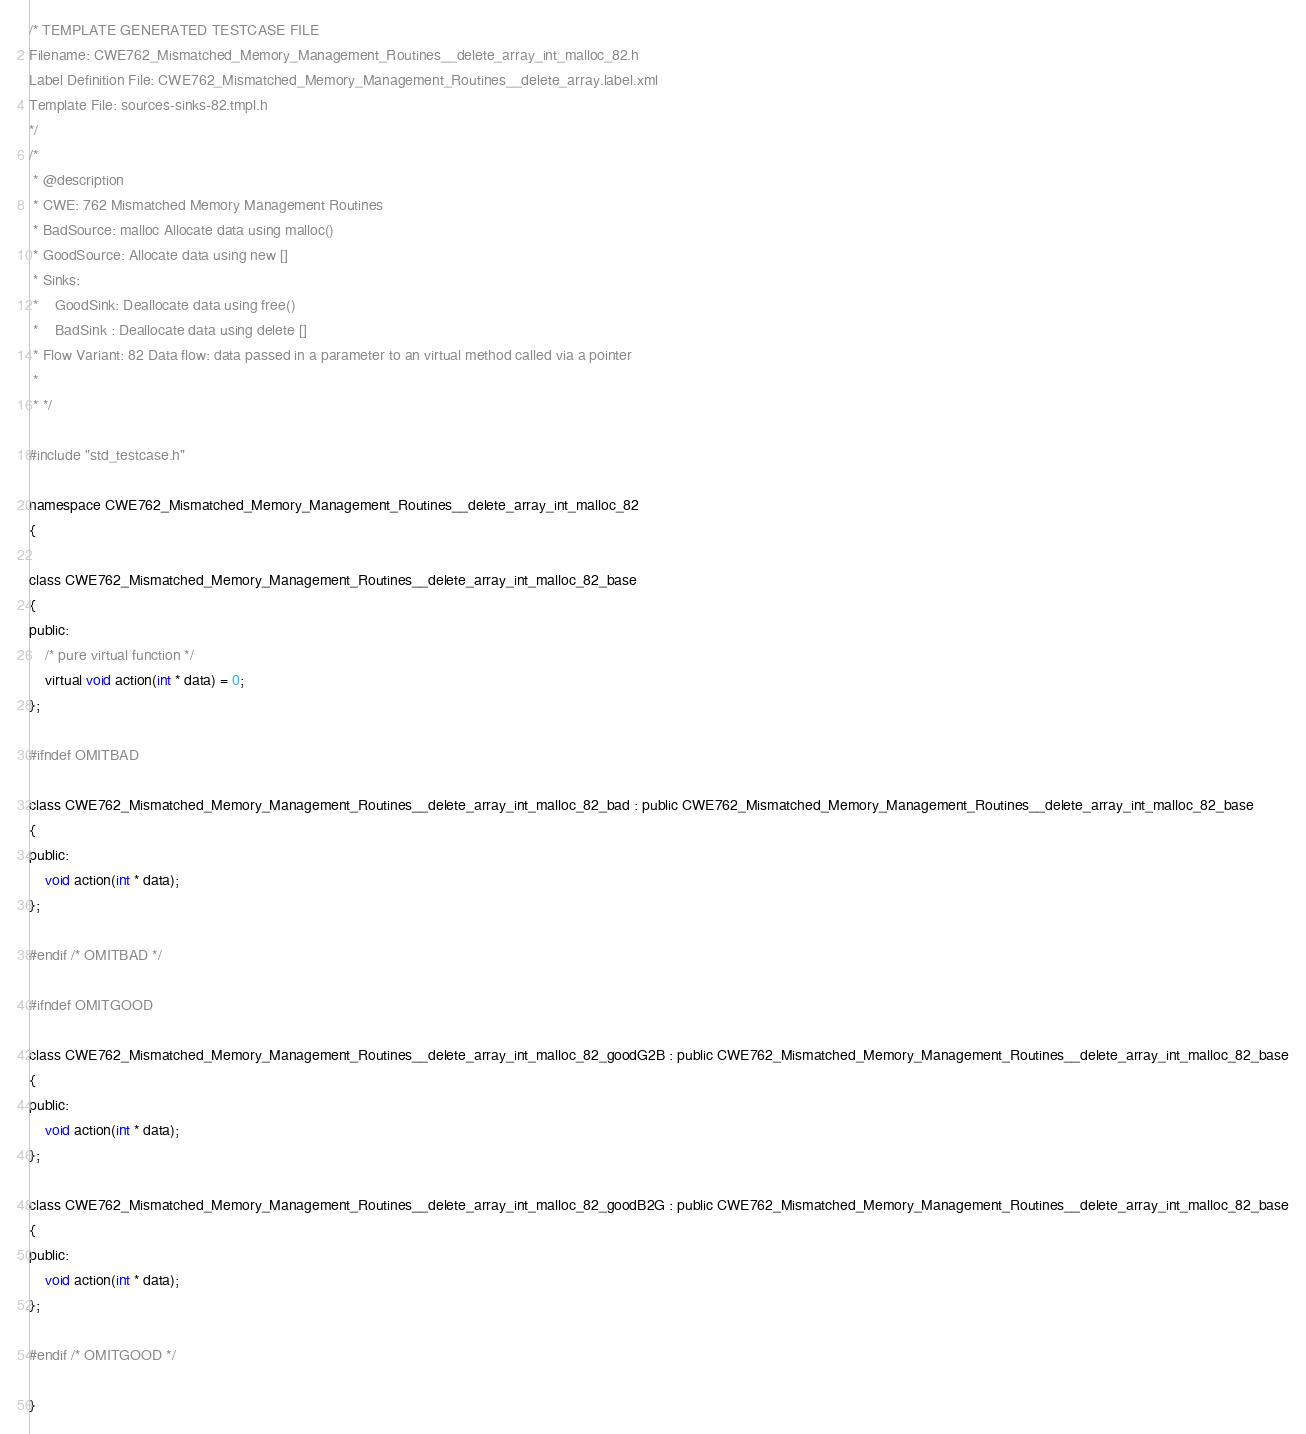<code> <loc_0><loc_0><loc_500><loc_500><_C_>/* TEMPLATE GENERATED TESTCASE FILE
Filename: CWE762_Mismatched_Memory_Management_Routines__delete_array_int_malloc_82.h
Label Definition File: CWE762_Mismatched_Memory_Management_Routines__delete_array.label.xml
Template File: sources-sinks-82.tmpl.h
*/
/*
 * @description
 * CWE: 762 Mismatched Memory Management Routines
 * BadSource: malloc Allocate data using malloc()
 * GoodSource: Allocate data using new []
 * Sinks:
 *    GoodSink: Deallocate data using free()
 *    BadSink : Deallocate data using delete []
 * Flow Variant: 82 Data flow: data passed in a parameter to an virtual method called via a pointer
 *
 * */

#include "std_testcase.h"

namespace CWE762_Mismatched_Memory_Management_Routines__delete_array_int_malloc_82
{

class CWE762_Mismatched_Memory_Management_Routines__delete_array_int_malloc_82_base
{
public:
    /* pure virtual function */
    virtual void action(int * data) = 0;
};

#ifndef OMITBAD

class CWE762_Mismatched_Memory_Management_Routines__delete_array_int_malloc_82_bad : public CWE762_Mismatched_Memory_Management_Routines__delete_array_int_malloc_82_base
{
public:
    void action(int * data);
};

#endif /* OMITBAD */

#ifndef OMITGOOD

class CWE762_Mismatched_Memory_Management_Routines__delete_array_int_malloc_82_goodG2B : public CWE762_Mismatched_Memory_Management_Routines__delete_array_int_malloc_82_base
{
public:
    void action(int * data);
};

class CWE762_Mismatched_Memory_Management_Routines__delete_array_int_malloc_82_goodB2G : public CWE762_Mismatched_Memory_Management_Routines__delete_array_int_malloc_82_base
{
public:
    void action(int * data);
};

#endif /* OMITGOOD */

}
</code> 